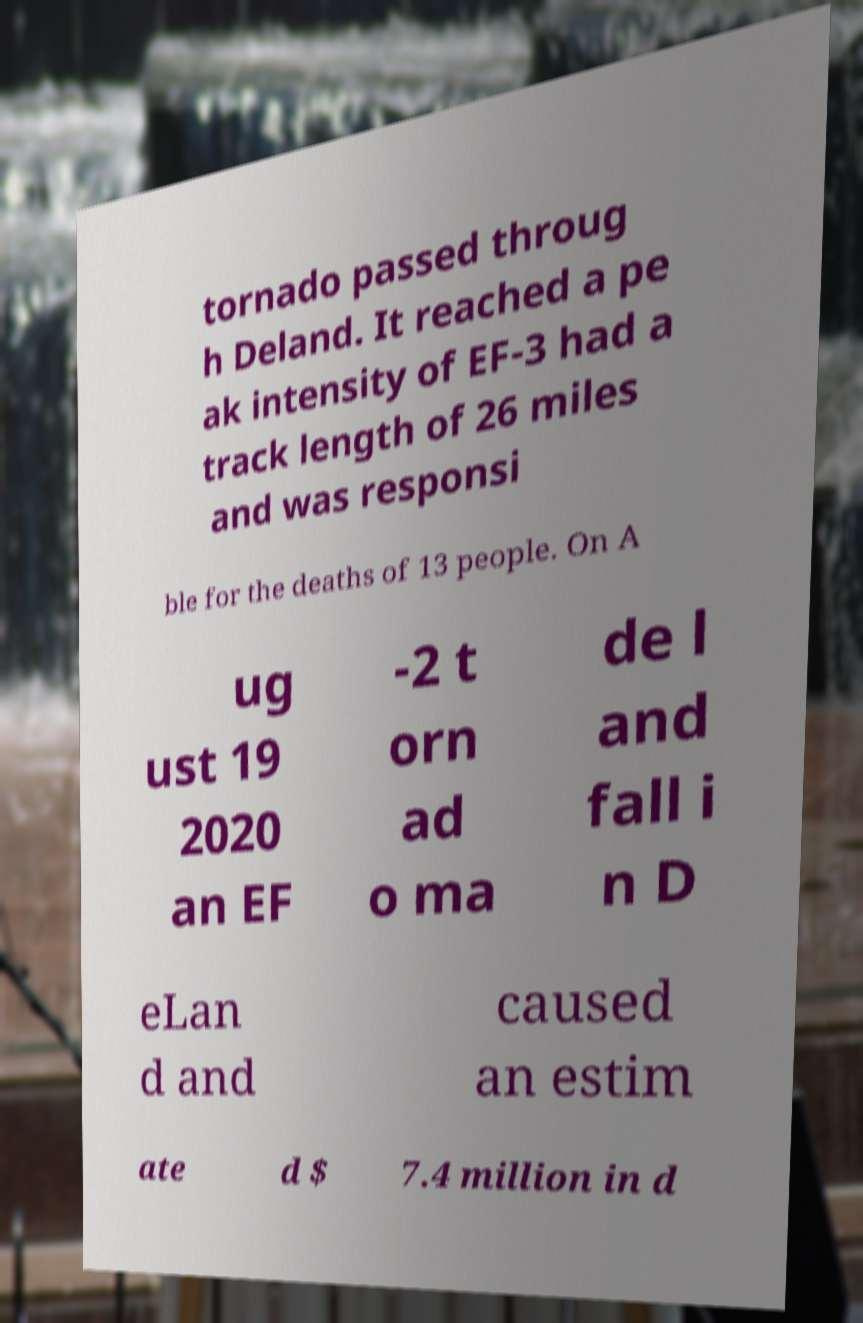Can you accurately transcribe the text from the provided image for me? tornado passed throug h Deland. It reached a pe ak intensity of EF-3 had a track length of 26 miles and was responsi ble for the deaths of 13 people. On A ug ust 19 2020 an EF -2 t orn ad o ma de l and fall i n D eLan d and caused an estim ate d $ 7.4 million in d 